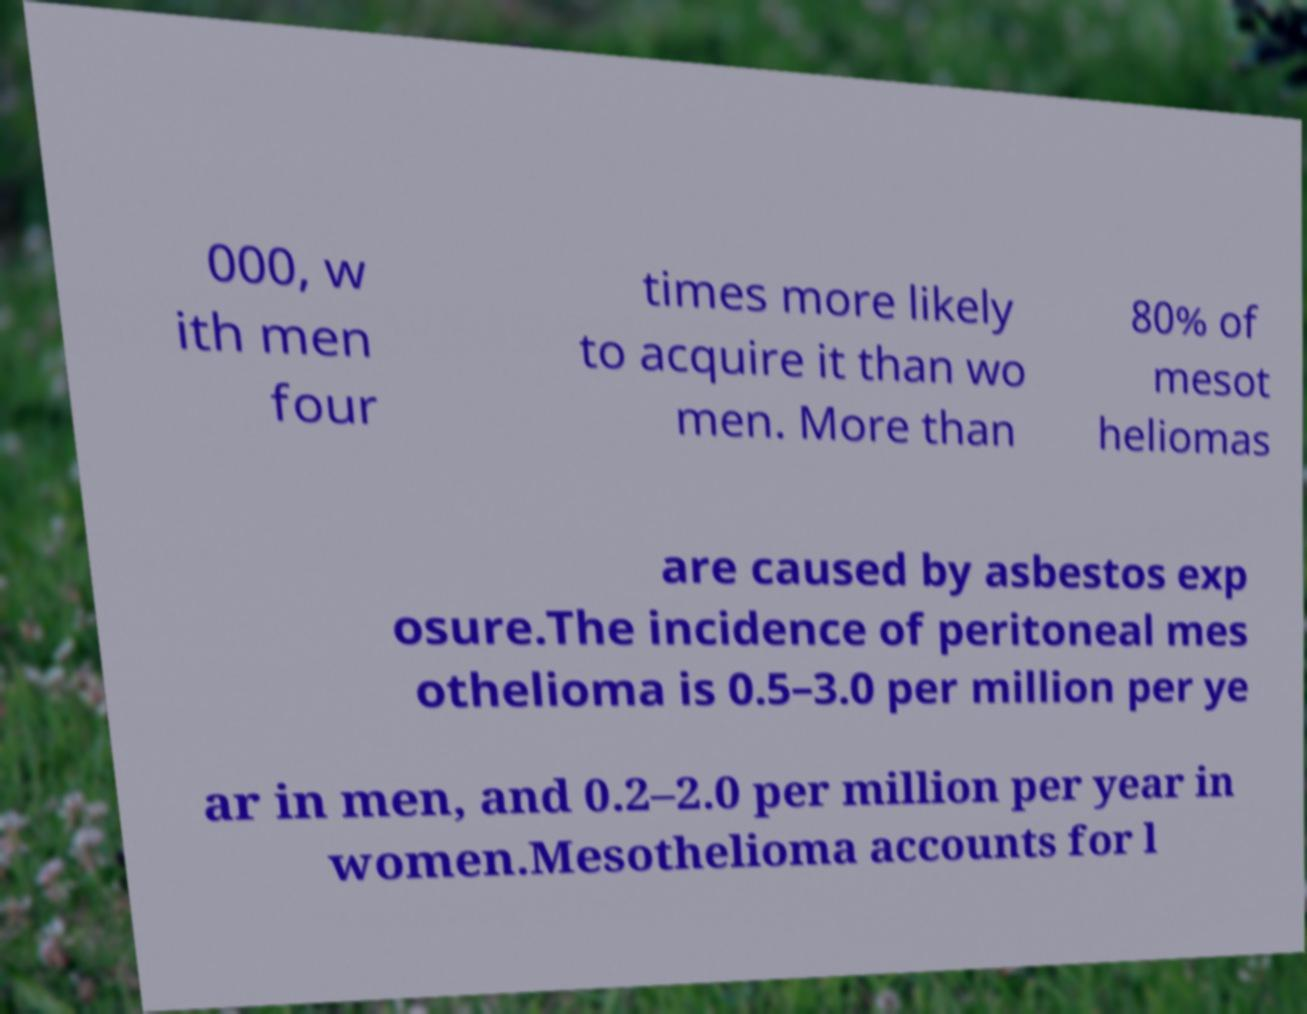There's text embedded in this image that I need extracted. Can you transcribe it verbatim? 000, w ith men four times more likely to acquire it than wo men. More than 80% of mesot heliomas are caused by asbestos exp osure.The incidence of peritoneal mes othelioma is 0.5–3.0 per million per ye ar in men, and 0.2–2.0 per million per year in women.Mesothelioma accounts for l 